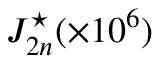<formula> <loc_0><loc_0><loc_500><loc_500>J _ { 2 n } ^ { ^ { * } } ( \times 1 0 ^ { 6 } )</formula> 